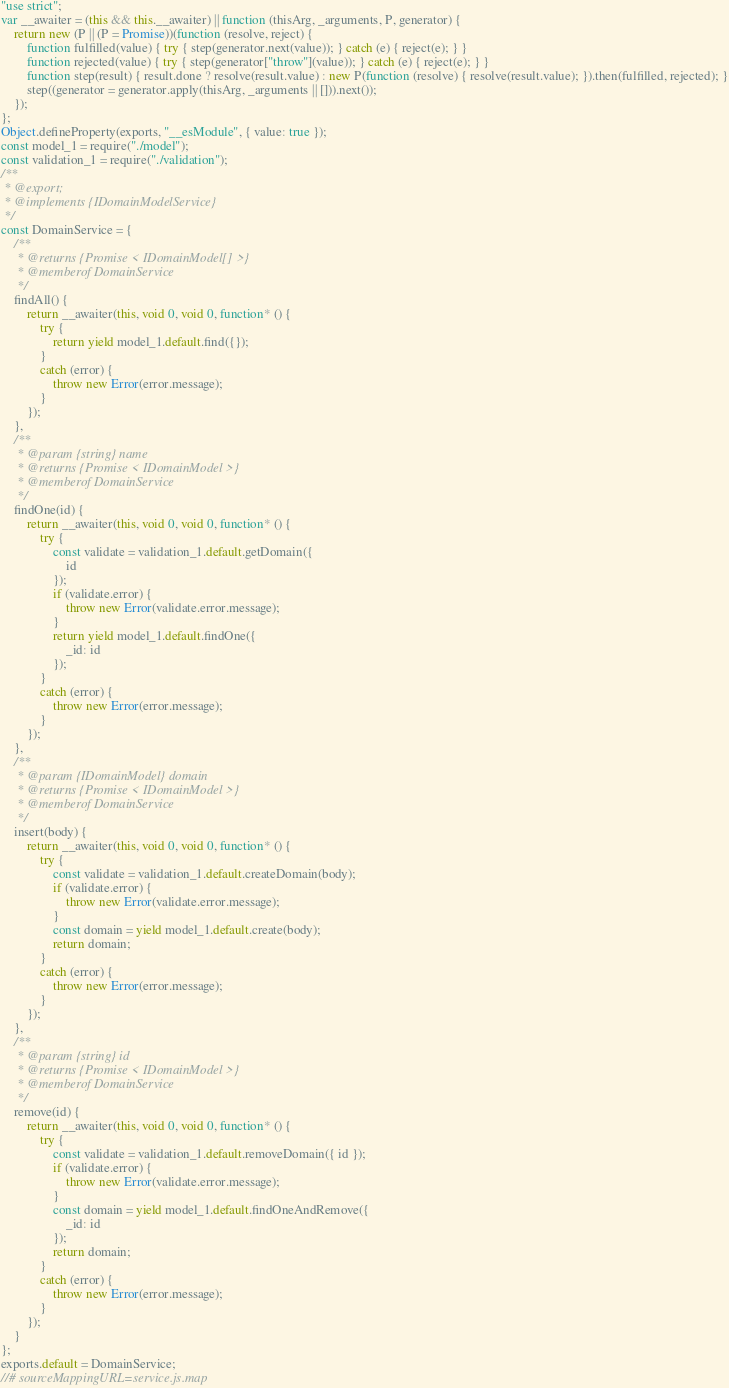Convert code to text. <code><loc_0><loc_0><loc_500><loc_500><_JavaScript_>"use strict";
var __awaiter = (this && this.__awaiter) || function (thisArg, _arguments, P, generator) {
    return new (P || (P = Promise))(function (resolve, reject) {
        function fulfilled(value) { try { step(generator.next(value)); } catch (e) { reject(e); } }
        function rejected(value) { try { step(generator["throw"](value)); } catch (e) { reject(e); } }
        function step(result) { result.done ? resolve(result.value) : new P(function (resolve) { resolve(result.value); }).then(fulfilled, rejected); }
        step((generator = generator.apply(thisArg, _arguments || [])).next());
    });
};
Object.defineProperty(exports, "__esModule", { value: true });
const model_1 = require("./model");
const validation_1 = require("./validation");
/**
 * @export;
 * @implements {IDomainModelService}
 */
const DomainService = {
    /**
     * @returns {Promise < IDomainModel[] >}
     * @memberof DomainService
     */
    findAll() {
        return __awaiter(this, void 0, void 0, function* () {
            try {
                return yield model_1.default.find({});
            }
            catch (error) {
                throw new Error(error.message);
            }
        });
    },
    /**
     * @param {string} name
     * @returns {Promise < IDomainModel >}
     * @memberof DomainService
     */
    findOne(id) {
        return __awaiter(this, void 0, void 0, function* () {
            try {
                const validate = validation_1.default.getDomain({
                    id
                });
                if (validate.error) {
                    throw new Error(validate.error.message);
                }
                return yield model_1.default.findOne({
                    _id: id
                });
            }
            catch (error) {
                throw new Error(error.message);
            }
        });
    },
    /**
     * @param {IDomainModel} domain
     * @returns {Promise < IDomainModel >}
     * @memberof DomainService
     */
    insert(body) {
        return __awaiter(this, void 0, void 0, function* () {
            try {
                const validate = validation_1.default.createDomain(body);
                if (validate.error) {
                    throw new Error(validate.error.message);
                }
                const domain = yield model_1.default.create(body);
                return domain;
            }
            catch (error) {
                throw new Error(error.message);
            }
        });
    },
    /**
     * @param {string} id
     * @returns {Promise < IDomainModel >}
     * @memberof DomainService
     */
    remove(id) {
        return __awaiter(this, void 0, void 0, function* () {
            try {
                const validate = validation_1.default.removeDomain({ id });
                if (validate.error) {
                    throw new Error(validate.error.message);
                }
                const domain = yield model_1.default.findOneAndRemove({
                    _id: id
                });
                return domain;
            }
            catch (error) {
                throw new Error(error.message);
            }
        });
    }
};
exports.default = DomainService;
//# sourceMappingURL=service.js.map</code> 